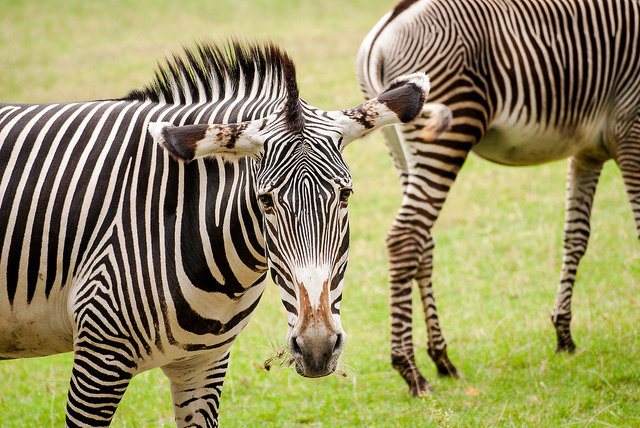What might these zebras be doing at the moment this picture was taken? The zebras in the photo seem at ease in their environment, possibly grazing or simply enjoying a quiet moment in the day. The one facing the viewer appears particularly alert and observant, perhaps keeping watch for any potential threats or disturbances. 